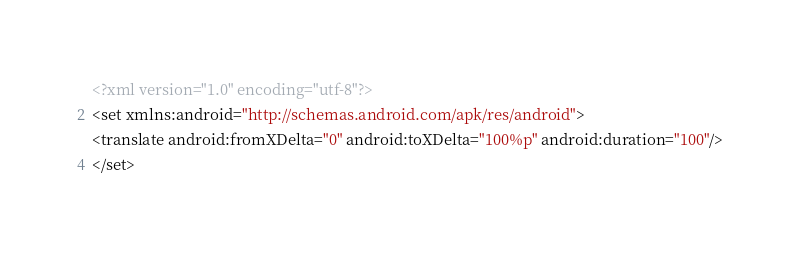<code> <loc_0><loc_0><loc_500><loc_500><_XML_><?xml version="1.0" encoding="utf-8"?>
<set xmlns:android="http://schemas.android.com/apk/res/android">
<translate android:fromXDelta="0" android:toXDelta="100%p" android:duration="100"/>
</set>
</code> 